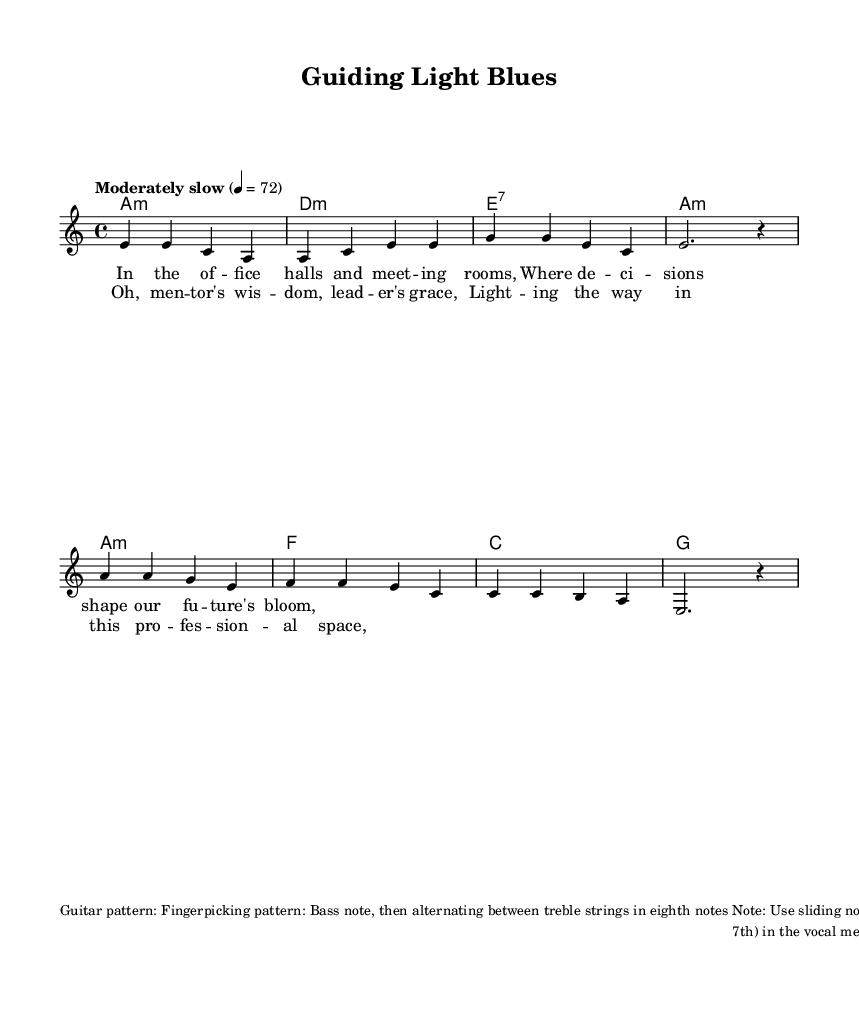What is the key signature of this music? The key signature is A minor, as indicated by the key signature notation, which shows no sharps or flats.
Answer: A minor What is the time signature of this music? The time signature is 4/4, which can be identified from the time signature notation placed at the beginning of the score.
Answer: 4/4 What tempo marking is provided for this music? The tempo marking is "Moderately slow" with a metronome indication of 72 beats per minute, as specified at the beginning of the score.
Answer: Moderately slow How many chords are in the verse section? There are four chords in the verse section, which can be seen represented in the harmonies block for the verse portion of the score.
Answer: Four What type of guitar pattern is suggested? The suggested guitar pattern is a fingerpicking pattern, which is described in the markup section indicating the playing technique for the guitar.
Answer: Fingerpicking Why are blue notes important in this piece? Blue notes, specifically the flattened third and seventh, are integral to the blues genre as they add emotional depth and authenticity to the melody, enhancing the overall blues feel articulated in the markup.
Answer: Emotional depth 